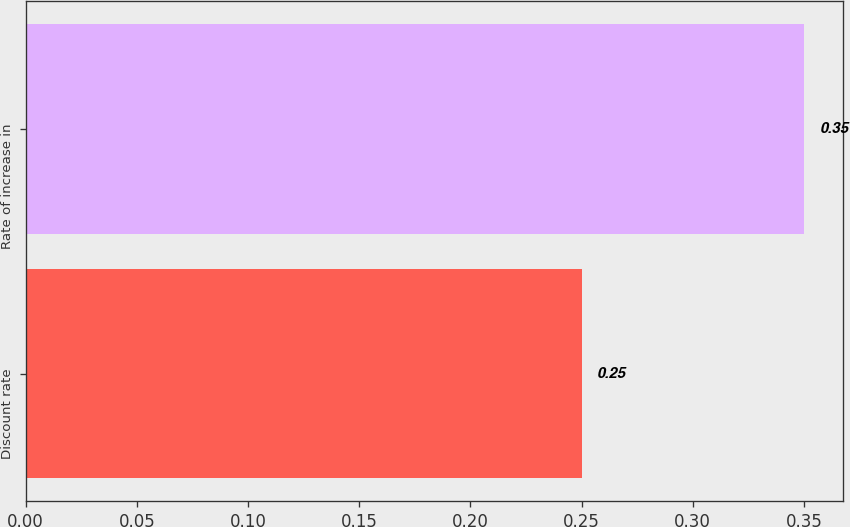Convert chart. <chart><loc_0><loc_0><loc_500><loc_500><bar_chart><fcel>Discount rate<fcel>Rate of increase in<nl><fcel>0.25<fcel>0.35<nl></chart> 